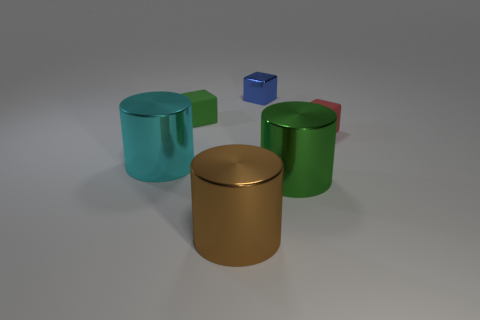What could be the function of these objects if they were real? The green and blue cylinders appear to be containers, potentially for storing items, given their shape and lids. The red and blue smaller cubes could serve as weights or toy blocks, judging by their size and solid appearance. Among these objects, which one seems out of place, and why? The small blue cube seems out of place. Unlike the other objects, which are larger and cylindrical, this cube is much smaller and geometrically distinct, indicating it may serve a different purpose or belong to a separate set. 